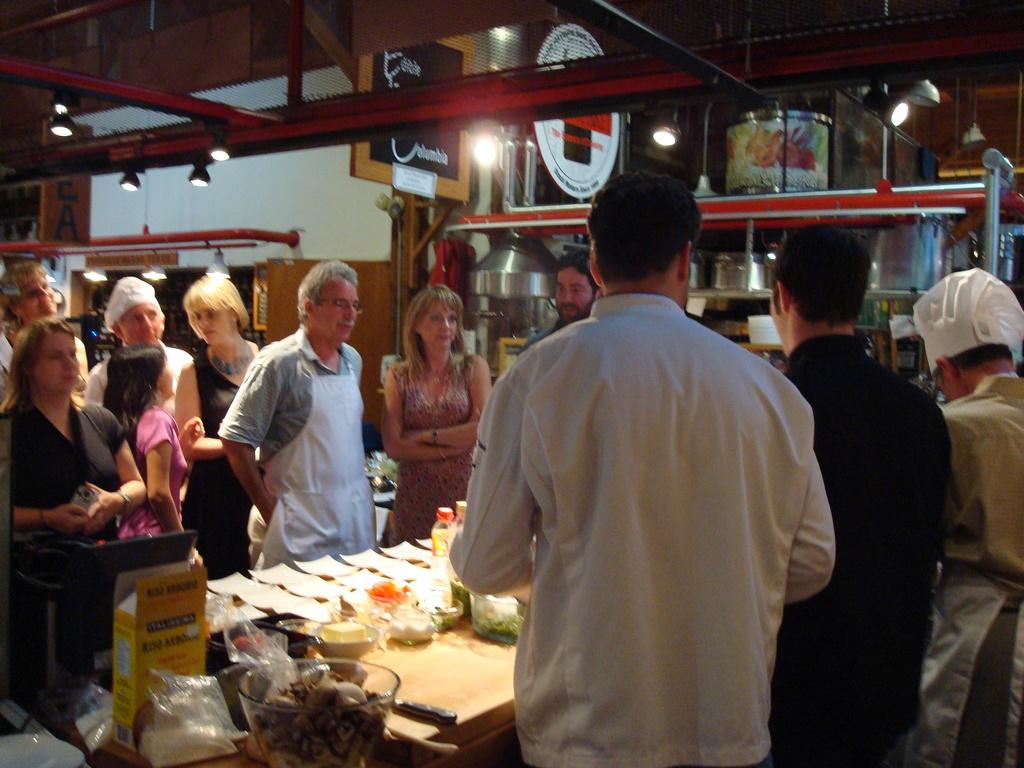Who or what can be seen in the image? There are people in the image. What else can be seen in the image besides the people? There are objects on tables and lights attached to the roof in the image. Are there any storage spaces visible in the image? Yes, there are objects in shelves in the image. What is the name of the person writing on the table in the image? There is no person writing on the table in the image. How does the image start? The image does not have a beginning or end; it is a static representation. 